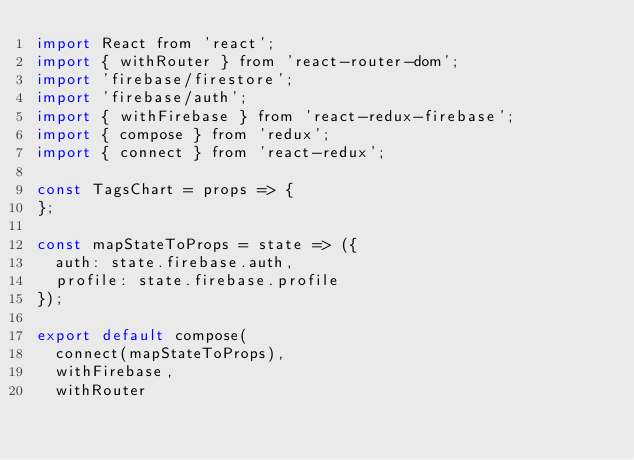<code> <loc_0><loc_0><loc_500><loc_500><_JavaScript_>import React from 'react';
import { withRouter } from 'react-router-dom';
import 'firebase/firestore';
import 'firebase/auth';
import { withFirebase } from 'react-redux-firebase';
import { compose } from 'redux';
import { connect } from 'react-redux';

const TagsChart = props => {
};

const mapStateToProps = state => ({
	auth: state.firebase.auth,
	profile: state.firebase.profile
});

export default compose(
	connect(mapStateToProps),
	withFirebase,
	withRouter</code> 